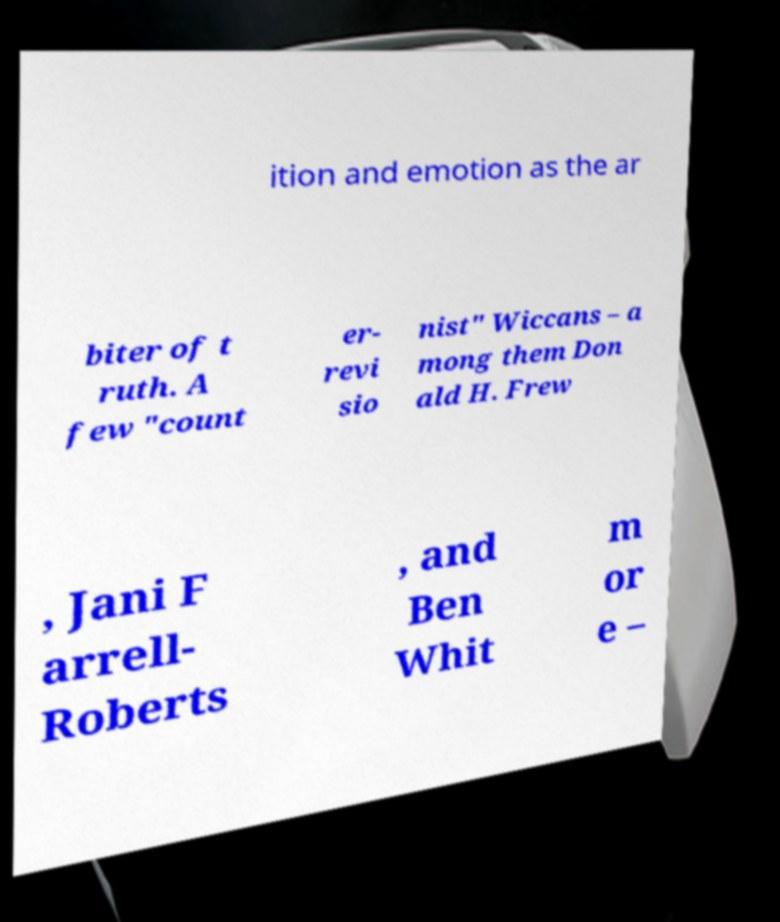Could you assist in decoding the text presented in this image and type it out clearly? ition and emotion as the ar biter of t ruth. A few "count er- revi sio nist" Wiccans – a mong them Don ald H. Frew , Jani F arrell- Roberts , and Ben Whit m or e – 